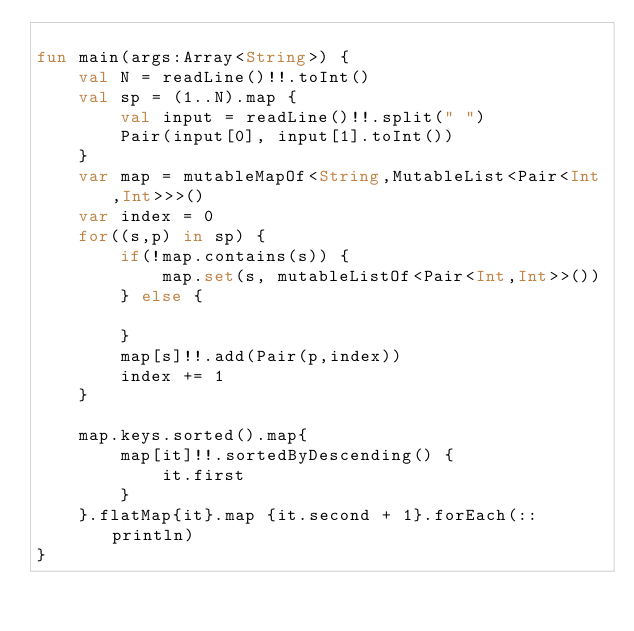Convert code to text. <code><loc_0><loc_0><loc_500><loc_500><_Kotlin_>
fun main(args:Array<String>) {
    val N = readLine()!!.toInt()
    val sp = (1..N).map {
        val input = readLine()!!.split(" ")
        Pair(input[0], input[1].toInt())
    }
    var map = mutableMapOf<String,MutableList<Pair<Int,Int>>>()
    var index = 0
    for((s,p) in sp) {
        if(!map.contains(s)) {
            map.set(s, mutableListOf<Pair<Int,Int>>())
        } else {
            
        }
        map[s]!!.add(Pair(p,index))
        index += 1
    }

    map.keys.sorted().map{
        map[it]!!.sortedByDescending() {
            it.first
        }
    }.flatMap{it}.map {it.second + 1}.forEach(::println)
}
 </code> 